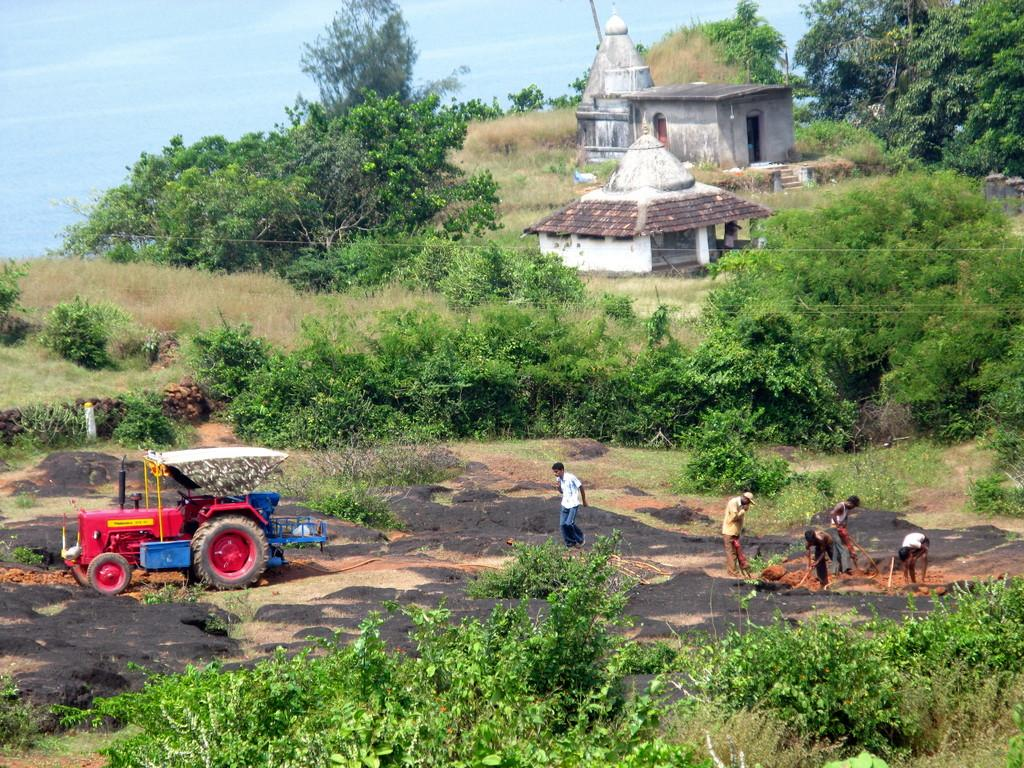What type of vegetation is present in the image? There is grass in the image. Who or what can be seen in the image? There are people in the image. What is located on the left side of the image? There is a vehicle on the left side of the image. What can be seen in the background of the image? There are trees and clouds in the sky in the background of the image. How many jellyfish are swimming in the grass in the image? There are no jellyfish present in the image; it features grass, people, a vehicle, trees, and clouds. What attraction is the main focus of the image? There is no specific attraction mentioned or depicted in the image; it shows a scene with grass, people, a vehicle, trees, and clouds. 